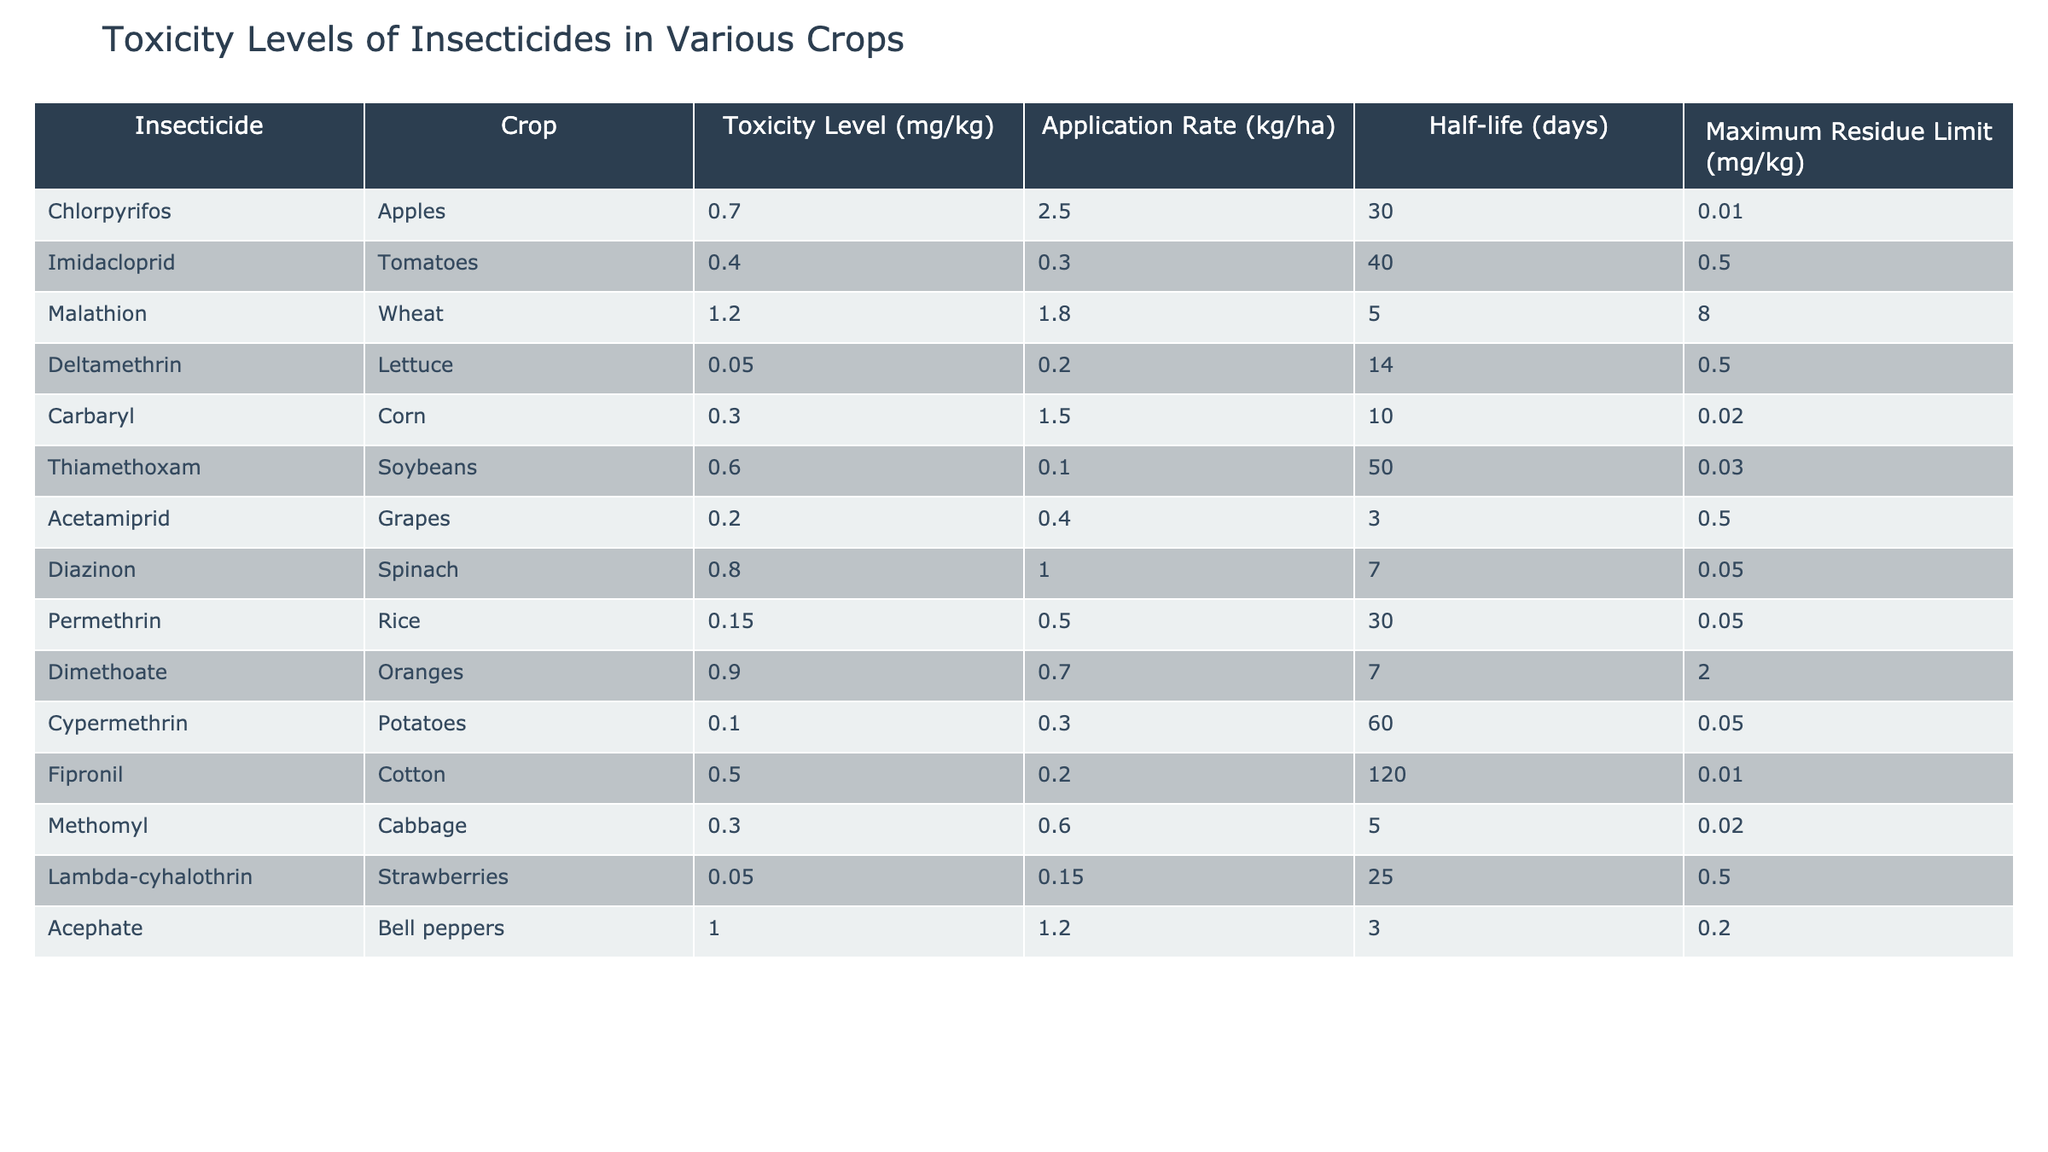What is the toxicity level of Acetamiprid in Grapes? The table directly lists the toxicity level of Acetamiprid under the crop Grapes, which is 0.2 mg/kg.
Answer: 0.2 mg/kg Which insecticide has the highest toxicity level? By reviewing the toxicity levels for all insecticides, Malathion has the highest toxicity level at 1.2 mg/kg.
Answer: Malathion What is the maximum residue limit for Chlorpyrifos? The maximum residue limit for Chlorpyrifos is stated in the table as 0.01 mg/kg.
Answer: 0.01 mg/kg How many insecticides have a toxicity level under 0.5 mg/kg? Count the insecticides with toxicity levels of 0.4 mg/kg or lower: Deltamethrin, Acetamiprid, Cypermethrin, and Lambda-cyhalothrin. That gives a total of 4 insecticides.
Answer: 4 What is the average toxicity level of the insecticides listed? Sum the toxicity levels (0.7 + 0.4 + 1.2 + 0.05 + 0.3 + 0.6 + 0.2 + 0.8 + 0.15 + 0.9 + 0.1 + 0.5 + 0.3 + 0.05 + 1.0) = 6.55 mg/kg, and divide by the number of insecticides (15), resulting in an average toxicity level of 0.437 mg/kg.
Answer: 0.437 mg/kg Is the half-life of Dimethoate longer than that of Thiamethoxam? The half-life of Dimethoate is 7 days, while the half-life of Thiamethoxam is 50 days. Since 7 days is less than 50 days, the statement is false.
Answer: No Which crop has the highest maximum residue limit, and what is that limit? By comparing maximum residue limits, Wheat has the highest limit at 8.0 mg/kg.
Answer: Wheat, 8.0 mg/kg If the application rate for Imidacloprid was increased to 1 kg/ha, what would be the potential impact on the toxicity level? While the toxicity level remains constant at 0.4 mg/kg, the application rate does not change the toxicity level itself; however, increasing the application rate means more insecticide applied per hectare. Therefore, toxicity level remains 0.4 mg/kg.
Answer: 0.4 mg/kg What is the difference in toxicity levels between Malathion and Carbaryl? The toxicity level of Malathion is 1.2 mg/kg and Carbaryl is 0.3 mg/kg. The difference is calculated as 1.2 - 0.3 = 0.9 mg/kg.
Answer: 0.9 mg/kg Do any insecticides have a maximum residue limit greater than 1 mg/kg? The table does not list any insecticides with a maximum residue limit exceeding 1 mg/kg, as Malathion is listed at 8.0 mg/kg but is a separate metric. The highest in the table is 8.0 mg/kg but pertains to the crop limit, not the insecticide.
Answer: No 